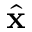<formula> <loc_0><loc_0><loc_500><loc_500>\hat { x }</formula> 